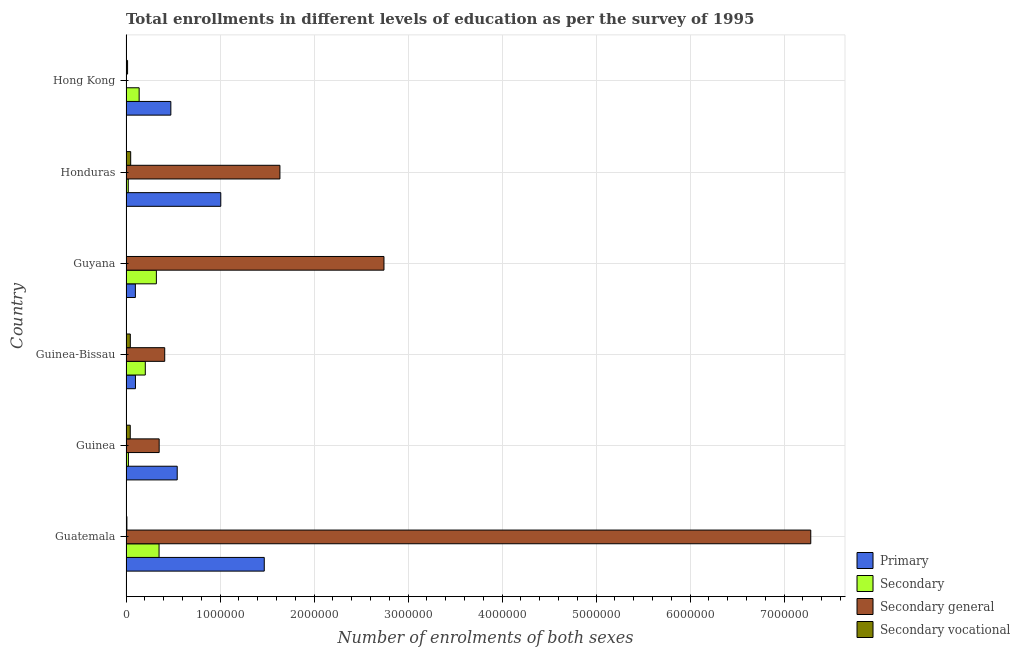How many groups of bars are there?
Your response must be concise. 6. Are the number of bars on each tick of the Y-axis equal?
Offer a terse response. Yes. How many bars are there on the 5th tick from the top?
Your answer should be compact. 4. What is the label of the 6th group of bars from the top?
Give a very brief answer. Guatemala. What is the number of enrolments in secondary vocational education in Guinea-Bissau?
Your response must be concise. 4.58e+04. Across all countries, what is the maximum number of enrolments in secondary general education?
Ensure brevity in your answer.  7.28e+06. Across all countries, what is the minimum number of enrolments in secondary education?
Provide a succinct answer. 2.39e+04. In which country was the number of enrolments in secondary education maximum?
Your answer should be very brief. Guatemala. In which country was the number of enrolments in primary education minimum?
Keep it short and to the point. Guyana. What is the total number of enrolments in secondary general education in the graph?
Your answer should be compact. 1.24e+07. What is the difference between the number of enrolments in secondary vocational education in Guinea and that in Guyana?
Your answer should be very brief. 4.44e+04. What is the difference between the number of enrolments in primary education in Guatemala and the number of enrolments in secondary vocational education in Guyana?
Offer a very short reply. 1.47e+06. What is the average number of enrolments in secondary education per country?
Make the answer very short. 1.78e+05. What is the difference between the number of enrolments in secondary education and number of enrolments in primary education in Hong Kong?
Provide a succinct answer. -3.37e+05. What is the ratio of the number of enrolments in secondary general education in Guinea-Bissau to that in Hong Kong?
Provide a succinct answer. 116.6. What is the difference between the highest and the second highest number of enrolments in primary education?
Provide a succinct answer. 4.63e+05. What is the difference between the highest and the lowest number of enrolments in primary education?
Offer a very short reply. 1.37e+06. Is the sum of the number of enrolments in secondary general education in Guinea-Bissau and Hong Kong greater than the maximum number of enrolments in secondary vocational education across all countries?
Offer a terse response. Yes. What does the 2nd bar from the top in Honduras represents?
Keep it short and to the point. Secondary general. What does the 1st bar from the bottom in Guatemala represents?
Offer a very short reply. Primary. How many bars are there?
Keep it short and to the point. 24. Are all the bars in the graph horizontal?
Provide a succinct answer. Yes. How many countries are there in the graph?
Give a very brief answer. 6. Are the values on the major ticks of X-axis written in scientific E-notation?
Your response must be concise. No. Does the graph contain any zero values?
Offer a terse response. No. How many legend labels are there?
Offer a terse response. 4. What is the title of the graph?
Offer a terse response. Total enrollments in different levels of education as per the survey of 1995. What is the label or title of the X-axis?
Ensure brevity in your answer.  Number of enrolments of both sexes. What is the Number of enrolments of both sexes in Primary in Guatemala?
Provide a short and direct response. 1.47e+06. What is the Number of enrolments of both sexes of Secondary in Guatemala?
Offer a terse response. 3.52e+05. What is the Number of enrolments of both sexes in Secondary general in Guatemala?
Provide a short and direct response. 7.28e+06. What is the Number of enrolments of both sexes in Secondary vocational in Guatemala?
Give a very brief answer. 9481. What is the Number of enrolments of both sexes in Primary in Guinea?
Offer a very short reply. 5.45e+05. What is the Number of enrolments of both sexes in Secondary in Guinea?
Keep it short and to the point. 2.56e+04. What is the Number of enrolments of both sexes of Secondary general in Guinea?
Make the answer very short. 3.53e+05. What is the Number of enrolments of both sexes of Secondary vocational in Guinea?
Your answer should be very brief. 4.51e+04. What is the Number of enrolments of both sexes in Primary in Guinea-Bissau?
Your response must be concise. 1.00e+05. What is the Number of enrolments of both sexes in Secondary in Guinea-Bissau?
Provide a succinct answer. 2.05e+05. What is the Number of enrolments of both sexes in Secondary general in Guinea-Bissau?
Provide a short and direct response. 4.12e+05. What is the Number of enrolments of both sexes of Secondary vocational in Guinea-Bissau?
Offer a very short reply. 4.58e+04. What is the Number of enrolments of both sexes of Primary in Guyana?
Provide a short and direct response. 9.97e+04. What is the Number of enrolments of both sexes in Secondary in Guyana?
Keep it short and to the point. 3.23e+05. What is the Number of enrolments of both sexes of Secondary general in Guyana?
Ensure brevity in your answer.  2.74e+06. What is the Number of enrolments of both sexes in Secondary vocational in Guyana?
Provide a succinct answer. 719. What is the Number of enrolments of both sexes of Primary in Honduras?
Provide a succinct answer. 1.01e+06. What is the Number of enrolments of both sexes in Secondary in Honduras?
Make the answer very short. 2.39e+04. What is the Number of enrolments of both sexes of Secondary general in Honduras?
Your answer should be very brief. 1.64e+06. What is the Number of enrolments of both sexes of Secondary vocational in Honduras?
Offer a terse response. 4.98e+04. What is the Number of enrolments of both sexes in Primary in Hong Kong?
Give a very brief answer. 4.77e+05. What is the Number of enrolments of both sexes of Secondary in Hong Kong?
Give a very brief answer. 1.40e+05. What is the Number of enrolments of both sexes of Secondary general in Hong Kong?
Provide a succinct answer. 3532. What is the Number of enrolments of both sexes of Secondary vocational in Hong Kong?
Your response must be concise. 1.66e+04. Across all countries, what is the maximum Number of enrolments of both sexes of Primary?
Make the answer very short. 1.47e+06. Across all countries, what is the maximum Number of enrolments of both sexes of Secondary?
Your response must be concise. 3.52e+05. Across all countries, what is the maximum Number of enrolments of both sexes in Secondary general?
Keep it short and to the point. 7.28e+06. Across all countries, what is the maximum Number of enrolments of both sexes in Secondary vocational?
Offer a terse response. 4.98e+04. Across all countries, what is the minimum Number of enrolments of both sexes of Primary?
Provide a short and direct response. 9.97e+04. Across all countries, what is the minimum Number of enrolments of both sexes in Secondary?
Ensure brevity in your answer.  2.39e+04. Across all countries, what is the minimum Number of enrolments of both sexes of Secondary general?
Provide a succinct answer. 3532. Across all countries, what is the minimum Number of enrolments of both sexes in Secondary vocational?
Your answer should be very brief. 719. What is the total Number of enrolments of both sexes in Primary in the graph?
Provide a short and direct response. 3.70e+06. What is the total Number of enrolments of both sexes of Secondary in the graph?
Keep it short and to the point. 1.07e+06. What is the total Number of enrolments of both sexes in Secondary general in the graph?
Your answer should be compact. 1.24e+07. What is the total Number of enrolments of both sexes in Secondary vocational in the graph?
Ensure brevity in your answer.  1.67e+05. What is the difference between the Number of enrolments of both sexes in Primary in Guatemala and that in Guinea?
Keep it short and to the point. 9.26e+05. What is the difference between the Number of enrolments of both sexes in Secondary in Guatemala and that in Guinea?
Offer a very short reply. 3.26e+05. What is the difference between the Number of enrolments of both sexes of Secondary general in Guatemala and that in Guinea?
Provide a short and direct response. 6.93e+06. What is the difference between the Number of enrolments of both sexes in Secondary vocational in Guatemala and that in Guinea?
Ensure brevity in your answer.  -3.56e+04. What is the difference between the Number of enrolments of both sexes in Primary in Guatemala and that in Guinea-Bissau?
Make the answer very short. 1.37e+06. What is the difference between the Number of enrolments of both sexes in Secondary in Guatemala and that in Guinea-Bissau?
Offer a very short reply. 1.46e+05. What is the difference between the Number of enrolments of both sexes of Secondary general in Guatemala and that in Guinea-Bissau?
Offer a terse response. 6.87e+06. What is the difference between the Number of enrolments of both sexes of Secondary vocational in Guatemala and that in Guinea-Bissau?
Keep it short and to the point. -3.63e+04. What is the difference between the Number of enrolments of both sexes of Primary in Guatemala and that in Guyana?
Keep it short and to the point. 1.37e+06. What is the difference between the Number of enrolments of both sexes in Secondary in Guatemala and that in Guyana?
Your answer should be compact. 2.85e+04. What is the difference between the Number of enrolments of both sexes in Secondary general in Guatemala and that in Guyana?
Give a very brief answer. 4.54e+06. What is the difference between the Number of enrolments of both sexes in Secondary vocational in Guatemala and that in Guyana?
Give a very brief answer. 8762. What is the difference between the Number of enrolments of both sexes in Primary in Guatemala and that in Honduras?
Provide a short and direct response. 4.63e+05. What is the difference between the Number of enrolments of both sexes of Secondary in Guatemala and that in Honduras?
Your answer should be very brief. 3.28e+05. What is the difference between the Number of enrolments of both sexes in Secondary general in Guatemala and that in Honduras?
Make the answer very short. 5.65e+06. What is the difference between the Number of enrolments of both sexes of Secondary vocational in Guatemala and that in Honduras?
Offer a terse response. -4.03e+04. What is the difference between the Number of enrolments of both sexes in Primary in Guatemala and that in Hong Kong?
Provide a succinct answer. 9.94e+05. What is the difference between the Number of enrolments of both sexes of Secondary in Guatemala and that in Hong Kong?
Provide a short and direct response. 2.12e+05. What is the difference between the Number of enrolments of both sexes of Secondary general in Guatemala and that in Hong Kong?
Give a very brief answer. 7.28e+06. What is the difference between the Number of enrolments of both sexes of Secondary vocational in Guatemala and that in Hong Kong?
Ensure brevity in your answer.  -7114. What is the difference between the Number of enrolments of both sexes of Primary in Guinea and that in Guinea-Bissau?
Ensure brevity in your answer.  4.44e+05. What is the difference between the Number of enrolments of both sexes in Secondary in Guinea and that in Guinea-Bissau?
Provide a short and direct response. -1.80e+05. What is the difference between the Number of enrolments of both sexes in Secondary general in Guinea and that in Guinea-Bissau?
Offer a terse response. -5.90e+04. What is the difference between the Number of enrolments of both sexes in Secondary vocational in Guinea and that in Guinea-Bissau?
Your response must be concise. -664. What is the difference between the Number of enrolments of both sexes in Primary in Guinea and that in Guyana?
Keep it short and to the point. 4.45e+05. What is the difference between the Number of enrolments of both sexes in Secondary in Guinea and that in Guyana?
Offer a terse response. -2.97e+05. What is the difference between the Number of enrolments of both sexes in Secondary general in Guinea and that in Guyana?
Make the answer very short. -2.39e+06. What is the difference between the Number of enrolments of both sexes of Secondary vocational in Guinea and that in Guyana?
Make the answer very short. 4.44e+04. What is the difference between the Number of enrolments of both sexes of Primary in Guinea and that in Honduras?
Give a very brief answer. -4.63e+05. What is the difference between the Number of enrolments of both sexes in Secondary in Guinea and that in Honduras?
Your answer should be compact. 1718. What is the difference between the Number of enrolments of both sexes of Secondary general in Guinea and that in Honduras?
Offer a terse response. -1.28e+06. What is the difference between the Number of enrolments of both sexes in Secondary vocational in Guinea and that in Honduras?
Provide a short and direct response. -4691. What is the difference between the Number of enrolments of both sexes in Primary in Guinea and that in Hong Kong?
Offer a very short reply. 6.79e+04. What is the difference between the Number of enrolments of both sexes in Secondary in Guinea and that in Hong Kong?
Your answer should be compact. -1.14e+05. What is the difference between the Number of enrolments of both sexes in Secondary general in Guinea and that in Hong Kong?
Your answer should be very brief. 3.49e+05. What is the difference between the Number of enrolments of both sexes of Secondary vocational in Guinea and that in Hong Kong?
Give a very brief answer. 2.85e+04. What is the difference between the Number of enrolments of both sexes in Primary in Guinea-Bissau and that in Guyana?
Ensure brevity in your answer.  705. What is the difference between the Number of enrolments of both sexes of Secondary in Guinea-Bissau and that in Guyana?
Offer a very short reply. -1.18e+05. What is the difference between the Number of enrolments of both sexes in Secondary general in Guinea-Bissau and that in Guyana?
Give a very brief answer. -2.33e+06. What is the difference between the Number of enrolments of both sexes in Secondary vocational in Guinea-Bissau and that in Guyana?
Your response must be concise. 4.51e+04. What is the difference between the Number of enrolments of both sexes in Primary in Guinea-Bissau and that in Honduras?
Offer a very short reply. -9.08e+05. What is the difference between the Number of enrolments of both sexes of Secondary in Guinea-Bissau and that in Honduras?
Your answer should be very brief. 1.81e+05. What is the difference between the Number of enrolments of both sexes of Secondary general in Guinea-Bissau and that in Honduras?
Offer a terse response. -1.23e+06. What is the difference between the Number of enrolments of both sexes in Secondary vocational in Guinea-Bissau and that in Honduras?
Offer a very short reply. -4027. What is the difference between the Number of enrolments of both sexes of Primary in Guinea-Bissau and that in Hong Kong?
Your answer should be very brief. -3.76e+05. What is the difference between the Number of enrolments of both sexes in Secondary in Guinea-Bissau and that in Hong Kong?
Offer a terse response. 6.54e+04. What is the difference between the Number of enrolments of both sexes of Secondary general in Guinea-Bissau and that in Hong Kong?
Offer a very short reply. 4.08e+05. What is the difference between the Number of enrolments of both sexes in Secondary vocational in Guinea-Bissau and that in Hong Kong?
Keep it short and to the point. 2.92e+04. What is the difference between the Number of enrolments of both sexes in Primary in Guyana and that in Honduras?
Provide a succinct answer. -9.08e+05. What is the difference between the Number of enrolments of both sexes in Secondary in Guyana and that in Honduras?
Provide a short and direct response. 2.99e+05. What is the difference between the Number of enrolments of both sexes in Secondary general in Guyana and that in Honduras?
Ensure brevity in your answer.  1.11e+06. What is the difference between the Number of enrolments of both sexes of Secondary vocational in Guyana and that in Honduras?
Provide a succinct answer. -4.91e+04. What is the difference between the Number of enrolments of both sexes in Primary in Guyana and that in Hong Kong?
Provide a short and direct response. -3.77e+05. What is the difference between the Number of enrolments of both sexes of Secondary in Guyana and that in Hong Kong?
Your answer should be compact. 1.83e+05. What is the difference between the Number of enrolments of both sexes of Secondary general in Guyana and that in Hong Kong?
Your answer should be very brief. 2.74e+06. What is the difference between the Number of enrolments of both sexes in Secondary vocational in Guyana and that in Hong Kong?
Your answer should be compact. -1.59e+04. What is the difference between the Number of enrolments of both sexes in Primary in Honduras and that in Hong Kong?
Keep it short and to the point. 5.31e+05. What is the difference between the Number of enrolments of both sexes of Secondary in Honduras and that in Hong Kong?
Your answer should be compact. -1.16e+05. What is the difference between the Number of enrolments of both sexes in Secondary general in Honduras and that in Hong Kong?
Provide a succinct answer. 1.63e+06. What is the difference between the Number of enrolments of both sexes of Secondary vocational in Honduras and that in Hong Kong?
Make the answer very short. 3.32e+04. What is the difference between the Number of enrolments of both sexes of Primary in Guatemala and the Number of enrolments of both sexes of Secondary in Guinea?
Ensure brevity in your answer.  1.45e+06. What is the difference between the Number of enrolments of both sexes in Primary in Guatemala and the Number of enrolments of both sexes in Secondary general in Guinea?
Ensure brevity in your answer.  1.12e+06. What is the difference between the Number of enrolments of both sexes of Primary in Guatemala and the Number of enrolments of both sexes of Secondary vocational in Guinea?
Your answer should be compact. 1.43e+06. What is the difference between the Number of enrolments of both sexes in Secondary in Guatemala and the Number of enrolments of both sexes in Secondary general in Guinea?
Keep it short and to the point. -1300. What is the difference between the Number of enrolments of both sexes in Secondary in Guatemala and the Number of enrolments of both sexes in Secondary vocational in Guinea?
Your answer should be very brief. 3.06e+05. What is the difference between the Number of enrolments of both sexes of Secondary general in Guatemala and the Number of enrolments of both sexes of Secondary vocational in Guinea?
Provide a short and direct response. 7.24e+06. What is the difference between the Number of enrolments of both sexes of Primary in Guatemala and the Number of enrolments of both sexes of Secondary in Guinea-Bissau?
Make the answer very short. 1.27e+06. What is the difference between the Number of enrolments of both sexes of Primary in Guatemala and the Number of enrolments of both sexes of Secondary general in Guinea-Bissau?
Offer a terse response. 1.06e+06. What is the difference between the Number of enrolments of both sexes of Primary in Guatemala and the Number of enrolments of both sexes of Secondary vocational in Guinea-Bissau?
Keep it short and to the point. 1.42e+06. What is the difference between the Number of enrolments of both sexes of Secondary in Guatemala and the Number of enrolments of both sexes of Secondary general in Guinea-Bissau?
Ensure brevity in your answer.  -6.03e+04. What is the difference between the Number of enrolments of both sexes in Secondary in Guatemala and the Number of enrolments of both sexes in Secondary vocational in Guinea-Bissau?
Keep it short and to the point. 3.06e+05. What is the difference between the Number of enrolments of both sexes of Secondary general in Guatemala and the Number of enrolments of both sexes of Secondary vocational in Guinea-Bissau?
Keep it short and to the point. 7.24e+06. What is the difference between the Number of enrolments of both sexes of Primary in Guatemala and the Number of enrolments of both sexes of Secondary in Guyana?
Provide a short and direct response. 1.15e+06. What is the difference between the Number of enrolments of both sexes in Primary in Guatemala and the Number of enrolments of both sexes in Secondary general in Guyana?
Keep it short and to the point. -1.27e+06. What is the difference between the Number of enrolments of both sexes of Primary in Guatemala and the Number of enrolments of both sexes of Secondary vocational in Guyana?
Give a very brief answer. 1.47e+06. What is the difference between the Number of enrolments of both sexes of Secondary in Guatemala and the Number of enrolments of both sexes of Secondary general in Guyana?
Your answer should be very brief. -2.39e+06. What is the difference between the Number of enrolments of both sexes in Secondary in Guatemala and the Number of enrolments of both sexes in Secondary vocational in Guyana?
Your response must be concise. 3.51e+05. What is the difference between the Number of enrolments of both sexes of Secondary general in Guatemala and the Number of enrolments of both sexes of Secondary vocational in Guyana?
Your response must be concise. 7.28e+06. What is the difference between the Number of enrolments of both sexes in Primary in Guatemala and the Number of enrolments of both sexes in Secondary in Honduras?
Make the answer very short. 1.45e+06. What is the difference between the Number of enrolments of both sexes in Primary in Guatemala and the Number of enrolments of both sexes in Secondary general in Honduras?
Provide a short and direct response. -1.66e+05. What is the difference between the Number of enrolments of both sexes in Primary in Guatemala and the Number of enrolments of both sexes in Secondary vocational in Honduras?
Ensure brevity in your answer.  1.42e+06. What is the difference between the Number of enrolments of both sexes in Secondary in Guatemala and the Number of enrolments of both sexes in Secondary general in Honduras?
Provide a succinct answer. -1.29e+06. What is the difference between the Number of enrolments of both sexes of Secondary in Guatemala and the Number of enrolments of both sexes of Secondary vocational in Honduras?
Your answer should be compact. 3.02e+05. What is the difference between the Number of enrolments of both sexes in Secondary general in Guatemala and the Number of enrolments of both sexes in Secondary vocational in Honduras?
Ensure brevity in your answer.  7.23e+06. What is the difference between the Number of enrolments of both sexes in Primary in Guatemala and the Number of enrolments of both sexes in Secondary in Hong Kong?
Offer a very short reply. 1.33e+06. What is the difference between the Number of enrolments of both sexes of Primary in Guatemala and the Number of enrolments of both sexes of Secondary general in Hong Kong?
Provide a short and direct response. 1.47e+06. What is the difference between the Number of enrolments of both sexes of Primary in Guatemala and the Number of enrolments of both sexes of Secondary vocational in Hong Kong?
Your response must be concise. 1.45e+06. What is the difference between the Number of enrolments of both sexes in Secondary in Guatemala and the Number of enrolments of both sexes in Secondary general in Hong Kong?
Provide a succinct answer. 3.48e+05. What is the difference between the Number of enrolments of both sexes of Secondary in Guatemala and the Number of enrolments of both sexes of Secondary vocational in Hong Kong?
Your answer should be compact. 3.35e+05. What is the difference between the Number of enrolments of both sexes of Secondary general in Guatemala and the Number of enrolments of both sexes of Secondary vocational in Hong Kong?
Give a very brief answer. 7.27e+06. What is the difference between the Number of enrolments of both sexes in Primary in Guinea and the Number of enrolments of both sexes in Secondary in Guinea-Bissau?
Ensure brevity in your answer.  3.40e+05. What is the difference between the Number of enrolments of both sexes in Primary in Guinea and the Number of enrolments of both sexes in Secondary general in Guinea-Bissau?
Ensure brevity in your answer.  1.33e+05. What is the difference between the Number of enrolments of both sexes in Primary in Guinea and the Number of enrolments of both sexes in Secondary vocational in Guinea-Bissau?
Keep it short and to the point. 4.99e+05. What is the difference between the Number of enrolments of both sexes of Secondary in Guinea and the Number of enrolments of both sexes of Secondary general in Guinea-Bissau?
Your response must be concise. -3.86e+05. What is the difference between the Number of enrolments of both sexes of Secondary in Guinea and the Number of enrolments of both sexes of Secondary vocational in Guinea-Bissau?
Your answer should be very brief. -2.02e+04. What is the difference between the Number of enrolments of both sexes of Secondary general in Guinea and the Number of enrolments of both sexes of Secondary vocational in Guinea-Bissau?
Offer a terse response. 3.07e+05. What is the difference between the Number of enrolments of both sexes in Primary in Guinea and the Number of enrolments of both sexes in Secondary in Guyana?
Your answer should be very brief. 2.22e+05. What is the difference between the Number of enrolments of both sexes in Primary in Guinea and the Number of enrolments of both sexes in Secondary general in Guyana?
Provide a short and direct response. -2.20e+06. What is the difference between the Number of enrolments of both sexes of Primary in Guinea and the Number of enrolments of both sexes of Secondary vocational in Guyana?
Your response must be concise. 5.44e+05. What is the difference between the Number of enrolments of both sexes of Secondary in Guinea and the Number of enrolments of both sexes of Secondary general in Guyana?
Provide a short and direct response. -2.72e+06. What is the difference between the Number of enrolments of both sexes of Secondary in Guinea and the Number of enrolments of both sexes of Secondary vocational in Guyana?
Provide a short and direct response. 2.49e+04. What is the difference between the Number of enrolments of both sexes in Secondary general in Guinea and the Number of enrolments of both sexes in Secondary vocational in Guyana?
Your answer should be very brief. 3.52e+05. What is the difference between the Number of enrolments of both sexes of Primary in Guinea and the Number of enrolments of both sexes of Secondary in Honduras?
Your answer should be compact. 5.21e+05. What is the difference between the Number of enrolments of both sexes in Primary in Guinea and the Number of enrolments of both sexes in Secondary general in Honduras?
Keep it short and to the point. -1.09e+06. What is the difference between the Number of enrolments of both sexes of Primary in Guinea and the Number of enrolments of both sexes of Secondary vocational in Honduras?
Offer a terse response. 4.95e+05. What is the difference between the Number of enrolments of both sexes of Secondary in Guinea and the Number of enrolments of both sexes of Secondary general in Honduras?
Provide a succinct answer. -1.61e+06. What is the difference between the Number of enrolments of both sexes of Secondary in Guinea and the Number of enrolments of both sexes of Secondary vocational in Honduras?
Offer a very short reply. -2.42e+04. What is the difference between the Number of enrolments of both sexes of Secondary general in Guinea and the Number of enrolments of both sexes of Secondary vocational in Honduras?
Your answer should be compact. 3.03e+05. What is the difference between the Number of enrolments of both sexes in Primary in Guinea and the Number of enrolments of both sexes in Secondary in Hong Kong?
Provide a succinct answer. 4.05e+05. What is the difference between the Number of enrolments of both sexes of Primary in Guinea and the Number of enrolments of both sexes of Secondary general in Hong Kong?
Offer a very short reply. 5.41e+05. What is the difference between the Number of enrolments of both sexes in Primary in Guinea and the Number of enrolments of both sexes in Secondary vocational in Hong Kong?
Your answer should be very brief. 5.28e+05. What is the difference between the Number of enrolments of both sexes in Secondary in Guinea and the Number of enrolments of both sexes in Secondary general in Hong Kong?
Your response must be concise. 2.21e+04. What is the difference between the Number of enrolments of both sexes in Secondary in Guinea and the Number of enrolments of both sexes in Secondary vocational in Hong Kong?
Keep it short and to the point. 9012. What is the difference between the Number of enrolments of both sexes of Secondary general in Guinea and the Number of enrolments of both sexes of Secondary vocational in Hong Kong?
Your answer should be compact. 3.36e+05. What is the difference between the Number of enrolments of both sexes in Primary in Guinea-Bissau and the Number of enrolments of both sexes in Secondary in Guyana?
Your answer should be very brief. -2.23e+05. What is the difference between the Number of enrolments of both sexes in Primary in Guinea-Bissau and the Number of enrolments of both sexes in Secondary general in Guyana?
Ensure brevity in your answer.  -2.64e+06. What is the difference between the Number of enrolments of both sexes in Primary in Guinea-Bissau and the Number of enrolments of both sexes in Secondary vocational in Guyana?
Provide a succinct answer. 9.96e+04. What is the difference between the Number of enrolments of both sexes in Secondary in Guinea-Bissau and the Number of enrolments of both sexes in Secondary general in Guyana?
Your answer should be very brief. -2.54e+06. What is the difference between the Number of enrolments of both sexes in Secondary in Guinea-Bissau and the Number of enrolments of both sexes in Secondary vocational in Guyana?
Offer a terse response. 2.04e+05. What is the difference between the Number of enrolments of both sexes of Secondary general in Guinea-Bissau and the Number of enrolments of both sexes of Secondary vocational in Guyana?
Provide a succinct answer. 4.11e+05. What is the difference between the Number of enrolments of both sexes of Primary in Guinea-Bissau and the Number of enrolments of both sexes of Secondary in Honduras?
Your answer should be very brief. 7.65e+04. What is the difference between the Number of enrolments of both sexes of Primary in Guinea-Bissau and the Number of enrolments of both sexes of Secondary general in Honduras?
Give a very brief answer. -1.54e+06. What is the difference between the Number of enrolments of both sexes in Primary in Guinea-Bissau and the Number of enrolments of both sexes in Secondary vocational in Honduras?
Offer a very short reply. 5.06e+04. What is the difference between the Number of enrolments of both sexes in Secondary in Guinea-Bissau and the Number of enrolments of both sexes in Secondary general in Honduras?
Make the answer very short. -1.43e+06. What is the difference between the Number of enrolments of both sexes in Secondary in Guinea-Bissau and the Number of enrolments of both sexes in Secondary vocational in Honduras?
Ensure brevity in your answer.  1.55e+05. What is the difference between the Number of enrolments of both sexes of Secondary general in Guinea-Bissau and the Number of enrolments of both sexes of Secondary vocational in Honduras?
Your response must be concise. 3.62e+05. What is the difference between the Number of enrolments of both sexes in Primary in Guinea-Bissau and the Number of enrolments of both sexes in Secondary in Hong Kong?
Your response must be concise. -3.94e+04. What is the difference between the Number of enrolments of both sexes in Primary in Guinea-Bissau and the Number of enrolments of both sexes in Secondary general in Hong Kong?
Give a very brief answer. 9.68e+04. What is the difference between the Number of enrolments of both sexes in Primary in Guinea-Bissau and the Number of enrolments of both sexes in Secondary vocational in Hong Kong?
Ensure brevity in your answer.  8.38e+04. What is the difference between the Number of enrolments of both sexes of Secondary in Guinea-Bissau and the Number of enrolments of both sexes of Secondary general in Hong Kong?
Give a very brief answer. 2.02e+05. What is the difference between the Number of enrolments of both sexes in Secondary in Guinea-Bissau and the Number of enrolments of both sexes in Secondary vocational in Hong Kong?
Ensure brevity in your answer.  1.89e+05. What is the difference between the Number of enrolments of both sexes of Secondary general in Guinea-Bissau and the Number of enrolments of both sexes of Secondary vocational in Hong Kong?
Offer a very short reply. 3.95e+05. What is the difference between the Number of enrolments of both sexes in Primary in Guyana and the Number of enrolments of both sexes in Secondary in Honduras?
Provide a short and direct response. 7.58e+04. What is the difference between the Number of enrolments of both sexes of Primary in Guyana and the Number of enrolments of both sexes of Secondary general in Honduras?
Give a very brief answer. -1.54e+06. What is the difference between the Number of enrolments of both sexes in Primary in Guyana and the Number of enrolments of both sexes in Secondary vocational in Honduras?
Provide a succinct answer. 4.99e+04. What is the difference between the Number of enrolments of both sexes in Secondary in Guyana and the Number of enrolments of both sexes in Secondary general in Honduras?
Keep it short and to the point. -1.31e+06. What is the difference between the Number of enrolments of both sexes of Secondary in Guyana and the Number of enrolments of both sexes of Secondary vocational in Honduras?
Provide a succinct answer. 2.73e+05. What is the difference between the Number of enrolments of both sexes in Secondary general in Guyana and the Number of enrolments of both sexes in Secondary vocational in Honduras?
Provide a succinct answer. 2.69e+06. What is the difference between the Number of enrolments of both sexes of Primary in Guyana and the Number of enrolments of both sexes of Secondary in Hong Kong?
Offer a very short reply. -4.01e+04. What is the difference between the Number of enrolments of both sexes of Primary in Guyana and the Number of enrolments of both sexes of Secondary general in Hong Kong?
Your answer should be compact. 9.61e+04. What is the difference between the Number of enrolments of both sexes of Primary in Guyana and the Number of enrolments of both sexes of Secondary vocational in Hong Kong?
Offer a very short reply. 8.31e+04. What is the difference between the Number of enrolments of both sexes of Secondary in Guyana and the Number of enrolments of both sexes of Secondary general in Hong Kong?
Your response must be concise. 3.19e+05. What is the difference between the Number of enrolments of both sexes in Secondary in Guyana and the Number of enrolments of both sexes in Secondary vocational in Hong Kong?
Ensure brevity in your answer.  3.06e+05. What is the difference between the Number of enrolments of both sexes in Secondary general in Guyana and the Number of enrolments of both sexes in Secondary vocational in Hong Kong?
Your response must be concise. 2.73e+06. What is the difference between the Number of enrolments of both sexes in Primary in Honduras and the Number of enrolments of both sexes in Secondary in Hong Kong?
Give a very brief answer. 8.68e+05. What is the difference between the Number of enrolments of both sexes in Primary in Honduras and the Number of enrolments of both sexes in Secondary general in Hong Kong?
Offer a terse response. 1.00e+06. What is the difference between the Number of enrolments of both sexes in Primary in Honduras and the Number of enrolments of both sexes in Secondary vocational in Hong Kong?
Give a very brief answer. 9.91e+05. What is the difference between the Number of enrolments of both sexes in Secondary in Honduras and the Number of enrolments of both sexes in Secondary general in Hong Kong?
Your answer should be compact. 2.04e+04. What is the difference between the Number of enrolments of both sexes of Secondary in Honduras and the Number of enrolments of both sexes of Secondary vocational in Hong Kong?
Your answer should be compact. 7294. What is the difference between the Number of enrolments of both sexes in Secondary general in Honduras and the Number of enrolments of both sexes in Secondary vocational in Hong Kong?
Your answer should be very brief. 1.62e+06. What is the average Number of enrolments of both sexes of Primary per country?
Your answer should be very brief. 6.17e+05. What is the average Number of enrolments of both sexes in Secondary per country?
Ensure brevity in your answer.  1.78e+05. What is the average Number of enrolments of both sexes of Secondary general per country?
Offer a terse response. 2.07e+06. What is the average Number of enrolments of both sexes of Secondary vocational per country?
Keep it short and to the point. 2.79e+04. What is the difference between the Number of enrolments of both sexes of Primary and Number of enrolments of both sexes of Secondary in Guatemala?
Provide a succinct answer. 1.12e+06. What is the difference between the Number of enrolments of both sexes of Primary and Number of enrolments of both sexes of Secondary general in Guatemala?
Your response must be concise. -5.81e+06. What is the difference between the Number of enrolments of both sexes in Primary and Number of enrolments of both sexes in Secondary vocational in Guatemala?
Provide a short and direct response. 1.46e+06. What is the difference between the Number of enrolments of both sexes in Secondary and Number of enrolments of both sexes in Secondary general in Guatemala?
Ensure brevity in your answer.  -6.93e+06. What is the difference between the Number of enrolments of both sexes of Secondary and Number of enrolments of both sexes of Secondary vocational in Guatemala?
Keep it short and to the point. 3.42e+05. What is the difference between the Number of enrolments of both sexes of Secondary general and Number of enrolments of both sexes of Secondary vocational in Guatemala?
Provide a short and direct response. 7.28e+06. What is the difference between the Number of enrolments of both sexes of Primary and Number of enrolments of both sexes of Secondary in Guinea?
Offer a terse response. 5.19e+05. What is the difference between the Number of enrolments of both sexes of Primary and Number of enrolments of both sexes of Secondary general in Guinea?
Give a very brief answer. 1.92e+05. What is the difference between the Number of enrolments of both sexes of Primary and Number of enrolments of both sexes of Secondary vocational in Guinea?
Offer a very short reply. 5.00e+05. What is the difference between the Number of enrolments of both sexes in Secondary and Number of enrolments of both sexes in Secondary general in Guinea?
Ensure brevity in your answer.  -3.27e+05. What is the difference between the Number of enrolments of both sexes of Secondary and Number of enrolments of both sexes of Secondary vocational in Guinea?
Offer a very short reply. -1.95e+04. What is the difference between the Number of enrolments of both sexes in Secondary general and Number of enrolments of both sexes in Secondary vocational in Guinea?
Ensure brevity in your answer.  3.08e+05. What is the difference between the Number of enrolments of both sexes of Primary and Number of enrolments of both sexes of Secondary in Guinea-Bissau?
Provide a succinct answer. -1.05e+05. What is the difference between the Number of enrolments of both sexes of Primary and Number of enrolments of both sexes of Secondary general in Guinea-Bissau?
Provide a succinct answer. -3.11e+05. What is the difference between the Number of enrolments of both sexes of Primary and Number of enrolments of both sexes of Secondary vocational in Guinea-Bissau?
Your answer should be very brief. 5.46e+04. What is the difference between the Number of enrolments of both sexes of Secondary and Number of enrolments of both sexes of Secondary general in Guinea-Bissau?
Make the answer very short. -2.07e+05. What is the difference between the Number of enrolments of both sexes in Secondary and Number of enrolments of both sexes in Secondary vocational in Guinea-Bissau?
Offer a very short reply. 1.59e+05. What is the difference between the Number of enrolments of both sexes in Secondary general and Number of enrolments of both sexes in Secondary vocational in Guinea-Bissau?
Ensure brevity in your answer.  3.66e+05. What is the difference between the Number of enrolments of both sexes of Primary and Number of enrolments of both sexes of Secondary in Guyana?
Your response must be concise. -2.23e+05. What is the difference between the Number of enrolments of both sexes in Primary and Number of enrolments of both sexes in Secondary general in Guyana?
Offer a terse response. -2.64e+06. What is the difference between the Number of enrolments of both sexes in Primary and Number of enrolments of both sexes in Secondary vocational in Guyana?
Provide a succinct answer. 9.89e+04. What is the difference between the Number of enrolments of both sexes in Secondary and Number of enrolments of both sexes in Secondary general in Guyana?
Ensure brevity in your answer.  -2.42e+06. What is the difference between the Number of enrolments of both sexes of Secondary and Number of enrolments of both sexes of Secondary vocational in Guyana?
Ensure brevity in your answer.  3.22e+05. What is the difference between the Number of enrolments of both sexes of Secondary general and Number of enrolments of both sexes of Secondary vocational in Guyana?
Your answer should be compact. 2.74e+06. What is the difference between the Number of enrolments of both sexes in Primary and Number of enrolments of both sexes in Secondary in Honduras?
Offer a terse response. 9.84e+05. What is the difference between the Number of enrolments of both sexes of Primary and Number of enrolments of both sexes of Secondary general in Honduras?
Offer a terse response. -6.29e+05. What is the difference between the Number of enrolments of both sexes of Primary and Number of enrolments of both sexes of Secondary vocational in Honduras?
Provide a short and direct response. 9.58e+05. What is the difference between the Number of enrolments of both sexes in Secondary and Number of enrolments of both sexes in Secondary general in Honduras?
Provide a succinct answer. -1.61e+06. What is the difference between the Number of enrolments of both sexes in Secondary and Number of enrolments of both sexes in Secondary vocational in Honduras?
Offer a terse response. -2.59e+04. What is the difference between the Number of enrolments of both sexes of Secondary general and Number of enrolments of both sexes of Secondary vocational in Honduras?
Make the answer very short. 1.59e+06. What is the difference between the Number of enrolments of both sexes in Primary and Number of enrolments of both sexes in Secondary in Hong Kong?
Keep it short and to the point. 3.37e+05. What is the difference between the Number of enrolments of both sexes in Primary and Number of enrolments of both sexes in Secondary general in Hong Kong?
Make the answer very short. 4.73e+05. What is the difference between the Number of enrolments of both sexes of Primary and Number of enrolments of both sexes of Secondary vocational in Hong Kong?
Give a very brief answer. 4.60e+05. What is the difference between the Number of enrolments of both sexes of Secondary and Number of enrolments of both sexes of Secondary general in Hong Kong?
Give a very brief answer. 1.36e+05. What is the difference between the Number of enrolments of both sexes in Secondary and Number of enrolments of both sexes in Secondary vocational in Hong Kong?
Your response must be concise. 1.23e+05. What is the difference between the Number of enrolments of both sexes in Secondary general and Number of enrolments of both sexes in Secondary vocational in Hong Kong?
Your response must be concise. -1.31e+04. What is the ratio of the Number of enrolments of both sexes of Primary in Guatemala to that in Guinea?
Make the answer very short. 2.7. What is the ratio of the Number of enrolments of both sexes in Secondary in Guatemala to that in Guinea?
Your answer should be compact. 13.73. What is the ratio of the Number of enrolments of both sexes of Secondary general in Guatemala to that in Guinea?
Offer a terse response. 20.65. What is the ratio of the Number of enrolments of both sexes in Secondary vocational in Guatemala to that in Guinea?
Offer a terse response. 0.21. What is the ratio of the Number of enrolments of both sexes of Primary in Guatemala to that in Guinea-Bissau?
Ensure brevity in your answer.  14.65. What is the ratio of the Number of enrolments of both sexes in Secondary in Guatemala to that in Guinea-Bissau?
Ensure brevity in your answer.  1.71. What is the ratio of the Number of enrolments of both sexes in Secondary general in Guatemala to that in Guinea-Bissau?
Your answer should be very brief. 17.69. What is the ratio of the Number of enrolments of both sexes in Secondary vocational in Guatemala to that in Guinea-Bissau?
Your answer should be very brief. 0.21. What is the ratio of the Number of enrolments of both sexes of Primary in Guatemala to that in Guyana?
Make the answer very short. 14.76. What is the ratio of the Number of enrolments of both sexes in Secondary in Guatemala to that in Guyana?
Your answer should be compact. 1.09. What is the ratio of the Number of enrolments of both sexes in Secondary general in Guatemala to that in Guyana?
Your answer should be compact. 2.65. What is the ratio of the Number of enrolments of both sexes of Secondary vocational in Guatemala to that in Guyana?
Give a very brief answer. 13.19. What is the ratio of the Number of enrolments of both sexes in Primary in Guatemala to that in Honduras?
Your response must be concise. 1.46. What is the ratio of the Number of enrolments of both sexes in Secondary in Guatemala to that in Honduras?
Offer a very short reply. 14.71. What is the ratio of the Number of enrolments of both sexes in Secondary general in Guatemala to that in Honduras?
Your answer should be very brief. 4.45. What is the ratio of the Number of enrolments of both sexes in Secondary vocational in Guatemala to that in Honduras?
Give a very brief answer. 0.19. What is the ratio of the Number of enrolments of both sexes in Primary in Guatemala to that in Hong Kong?
Offer a very short reply. 3.08. What is the ratio of the Number of enrolments of both sexes of Secondary in Guatemala to that in Hong Kong?
Provide a short and direct response. 2.51. What is the ratio of the Number of enrolments of both sexes of Secondary general in Guatemala to that in Hong Kong?
Keep it short and to the point. 2062.46. What is the ratio of the Number of enrolments of both sexes of Secondary vocational in Guatemala to that in Hong Kong?
Your answer should be very brief. 0.57. What is the ratio of the Number of enrolments of both sexes in Primary in Guinea to that in Guinea-Bissau?
Keep it short and to the point. 5.43. What is the ratio of the Number of enrolments of both sexes in Secondary in Guinea to that in Guinea-Bissau?
Provide a short and direct response. 0.12. What is the ratio of the Number of enrolments of both sexes in Secondary general in Guinea to that in Guinea-Bissau?
Ensure brevity in your answer.  0.86. What is the ratio of the Number of enrolments of both sexes of Secondary vocational in Guinea to that in Guinea-Bissau?
Keep it short and to the point. 0.99. What is the ratio of the Number of enrolments of both sexes of Primary in Guinea to that in Guyana?
Your answer should be very brief. 5.47. What is the ratio of the Number of enrolments of both sexes of Secondary in Guinea to that in Guyana?
Make the answer very short. 0.08. What is the ratio of the Number of enrolments of both sexes of Secondary general in Guinea to that in Guyana?
Your answer should be very brief. 0.13. What is the ratio of the Number of enrolments of both sexes of Secondary vocational in Guinea to that in Guyana?
Your answer should be compact. 62.74. What is the ratio of the Number of enrolments of both sexes in Primary in Guinea to that in Honduras?
Your response must be concise. 0.54. What is the ratio of the Number of enrolments of both sexes of Secondary in Guinea to that in Honduras?
Provide a succinct answer. 1.07. What is the ratio of the Number of enrolments of both sexes in Secondary general in Guinea to that in Honduras?
Give a very brief answer. 0.22. What is the ratio of the Number of enrolments of both sexes in Secondary vocational in Guinea to that in Honduras?
Provide a succinct answer. 0.91. What is the ratio of the Number of enrolments of both sexes in Primary in Guinea to that in Hong Kong?
Your response must be concise. 1.14. What is the ratio of the Number of enrolments of both sexes in Secondary in Guinea to that in Hong Kong?
Make the answer very short. 0.18. What is the ratio of the Number of enrolments of both sexes of Secondary general in Guinea to that in Hong Kong?
Your response must be concise. 99.89. What is the ratio of the Number of enrolments of both sexes in Secondary vocational in Guinea to that in Hong Kong?
Make the answer very short. 2.72. What is the ratio of the Number of enrolments of both sexes of Primary in Guinea-Bissau to that in Guyana?
Make the answer very short. 1.01. What is the ratio of the Number of enrolments of both sexes in Secondary in Guinea-Bissau to that in Guyana?
Offer a terse response. 0.64. What is the ratio of the Number of enrolments of both sexes in Secondary general in Guinea-Bissau to that in Guyana?
Offer a terse response. 0.15. What is the ratio of the Number of enrolments of both sexes in Secondary vocational in Guinea-Bissau to that in Guyana?
Offer a terse response. 63.67. What is the ratio of the Number of enrolments of both sexes in Primary in Guinea-Bissau to that in Honduras?
Your answer should be compact. 0.1. What is the ratio of the Number of enrolments of both sexes in Secondary in Guinea-Bissau to that in Honduras?
Your response must be concise. 8.59. What is the ratio of the Number of enrolments of both sexes of Secondary general in Guinea-Bissau to that in Honduras?
Give a very brief answer. 0.25. What is the ratio of the Number of enrolments of both sexes in Secondary vocational in Guinea-Bissau to that in Honduras?
Make the answer very short. 0.92. What is the ratio of the Number of enrolments of both sexes in Primary in Guinea-Bissau to that in Hong Kong?
Your response must be concise. 0.21. What is the ratio of the Number of enrolments of both sexes in Secondary in Guinea-Bissau to that in Hong Kong?
Provide a short and direct response. 1.47. What is the ratio of the Number of enrolments of both sexes in Secondary general in Guinea-Bissau to that in Hong Kong?
Your response must be concise. 116.6. What is the ratio of the Number of enrolments of both sexes of Secondary vocational in Guinea-Bissau to that in Hong Kong?
Offer a terse response. 2.76. What is the ratio of the Number of enrolments of both sexes in Primary in Guyana to that in Honduras?
Offer a terse response. 0.1. What is the ratio of the Number of enrolments of both sexes in Secondary in Guyana to that in Honduras?
Keep it short and to the point. 13.52. What is the ratio of the Number of enrolments of both sexes in Secondary general in Guyana to that in Honduras?
Give a very brief answer. 1.68. What is the ratio of the Number of enrolments of both sexes of Secondary vocational in Guyana to that in Honduras?
Give a very brief answer. 0.01. What is the ratio of the Number of enrolments of both sexes of Primary in Guyana to that in Hong Kong?
Make the answer very short. 0.21. What is the ratio of the Number of enrolments of both sexes of Secondary in Guyana to that in Hong Kong?
Keep it short and to the point. 2.31. What is the ratio of the Number of enrolments of both sexes in Secondary general in Guyana to that in Hong Kong?
Your answer should be compact. 776.97. What is the ratio of the Number of enrolments of both sexes of Secondary vocational in Guyana to that in Hong Kong?
Offer a very short reply. 0.04. What is the ratio of the Number of enrolments of both sexes of Primary in Honduras to that in Hong Kong?
Make the answer very short. 2.11. What is the ratio of the Number of enrolments of both sexes in Secondary in Honduras to that in Hong Kong?
Keep it short and to the point. 0.17. What is the ratio of the Number of enrolments of both sexes in Secondary general in Honduras to that in Hong Kong?
Ensure brevity in your answer.  463.54. What is the ratio of the Number of enrolments of both sexes of Secondary vocational in Honduras to that in Hong Kong?
Give a very brief answer. 3. What is the difference between the highest and the second highest Number of enrolments of both sexes of Primary?
Give a very brief answer. 4.63e+05. What is the difference between the highest and the second highest Number of enrolments of both sexes of Secondary?
Provide a short and direct response. 2.85e+04. What is the difference between the highest and the second highest Number of enrolments of both sexes in Secondary general?
Offer a very short reply. 4.54e+06. What is the difference between the highest and the second highest Number of enrolments of both sexes of Secondary vocational?
Offer a very short reply. 4027. What is the difference between the highest and the lowest Number of enrolments of both sexes in Primary?
Your answer should be compact. 1.37e+06. What is the difference between the highest and the lowest Number of enrolments of both sexes in Secondary?
Your answer should be very brief. 3.28e+05. What is the difference between the highest and the lowest Number of enrolments of both sexes of Secondary general?
Ensure brevity in your answer.  7.28e+06. What is the difference between the highest and the lowest Number of enrolments of both sexes of Secondary vocational?
Your answer should be very brief. 4.91e+04. 